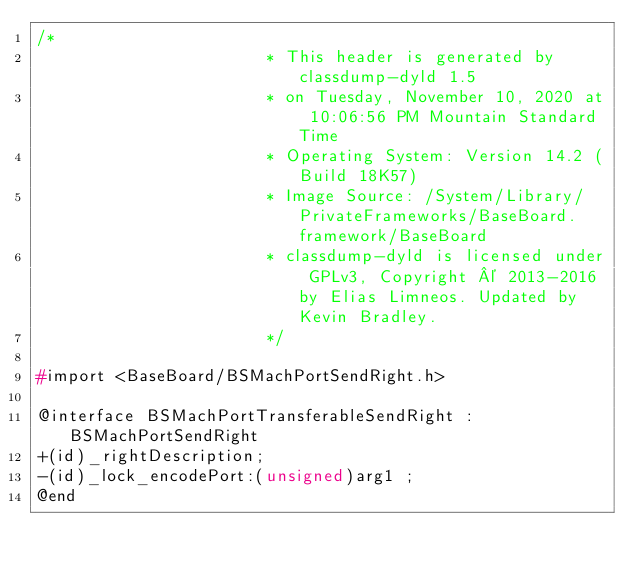Convert code to text. <code><loc_0><loc_0><loc_500><loc_500><_C_>/*
                       * This header is generated by classdump-dyld 1.5
                       * on Tuesday, November 10, 2020 at 10:06:56 PM Mountain Standard Time
                       * Operating System: Version 14.2 (Build 18K57)
                       * Image Source: /System/Library/PrivateFrameworks/BaseBoard.framework/BaseBoard
                       * classdump-dyld is licensed under GPLv3, Copyright © 2013-2016 by Elias Limneos. Updated by Kevin Bradley.
                       */

#import <BaseBoard/BSMachPortSendRight.h>

@interface BSMachPortTransferableSendRight : BSMachPortSendRight
+(id)_rightDescription;
-(id)_lock_encodePort:(unsigned)arg1 ;
@end

</code> 